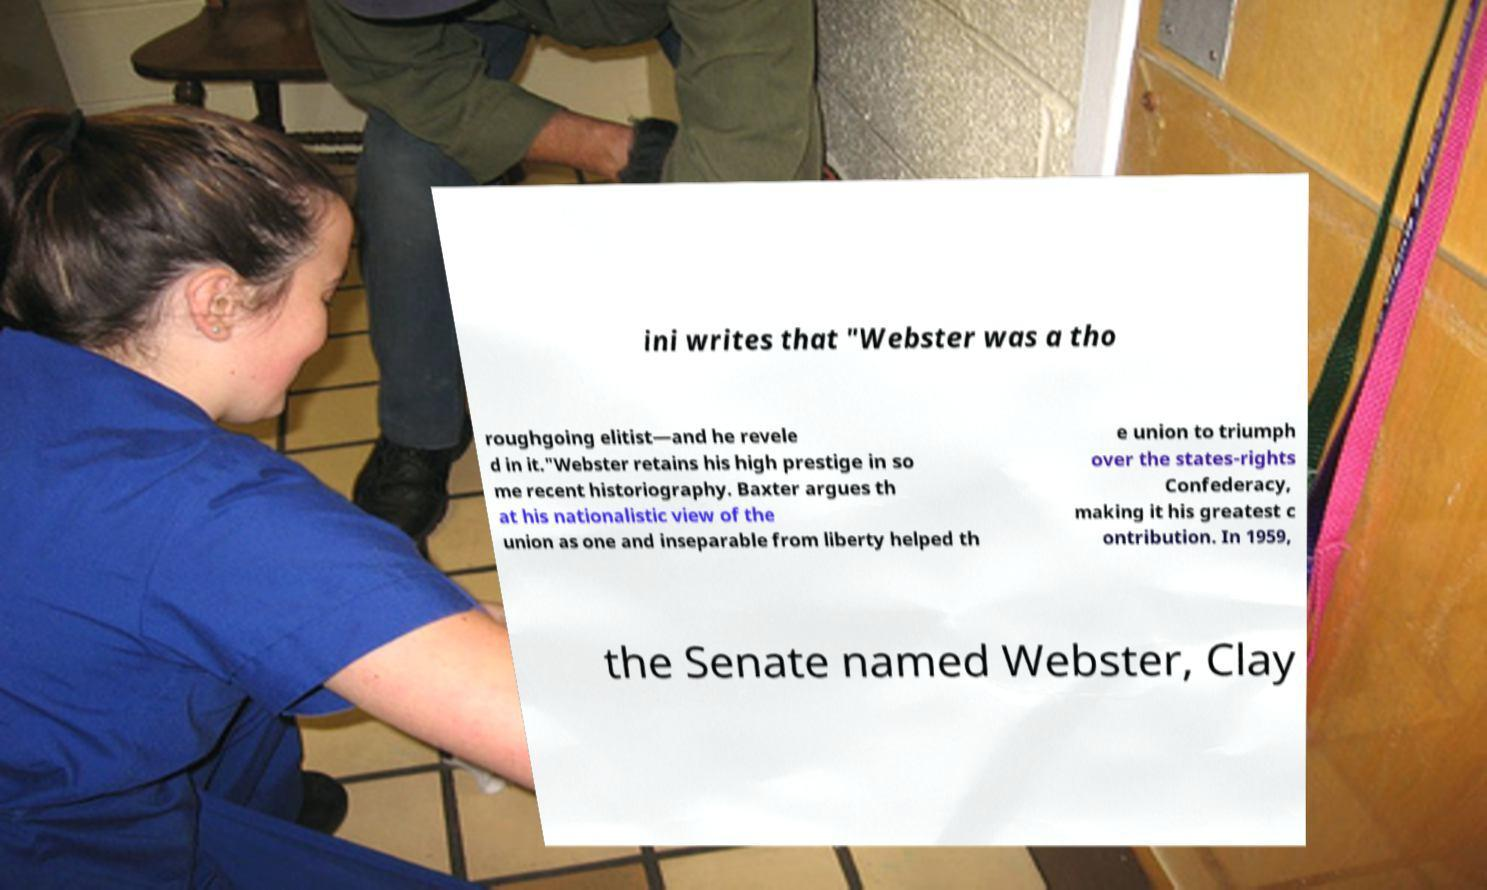For documentation purposes, I need the text within this image transcribed. Could you provide that? ini writes that "Webster was a tho roughgoing elitist—and he revele d in it."Webster retains his high prestige in so me recent historiography. Baxter argues th at his nationalistic view of the union as one and inseparable from liberty helped th e union to triumph over the states-rights Confederacy, making it his greatest c ontribution. In 1959, the Senate named Webster, Clay 